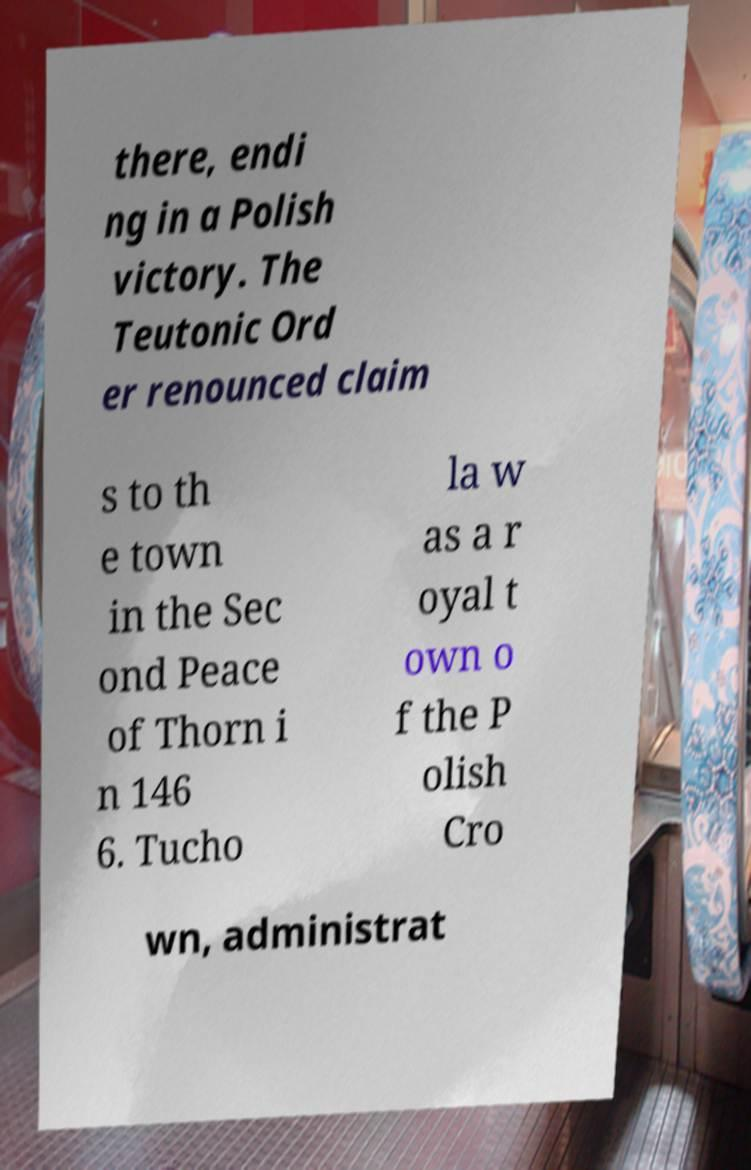Can you accurately transcribe the text from the provided image for me? there, endi ng in a Polish victory. The Teutonic Ord er renounced claim s to th e town in the Sec ond Peace of Thorn i n 146 6. Tucho la w as a r oyal t own o f the P olish Cro wn, administrat 